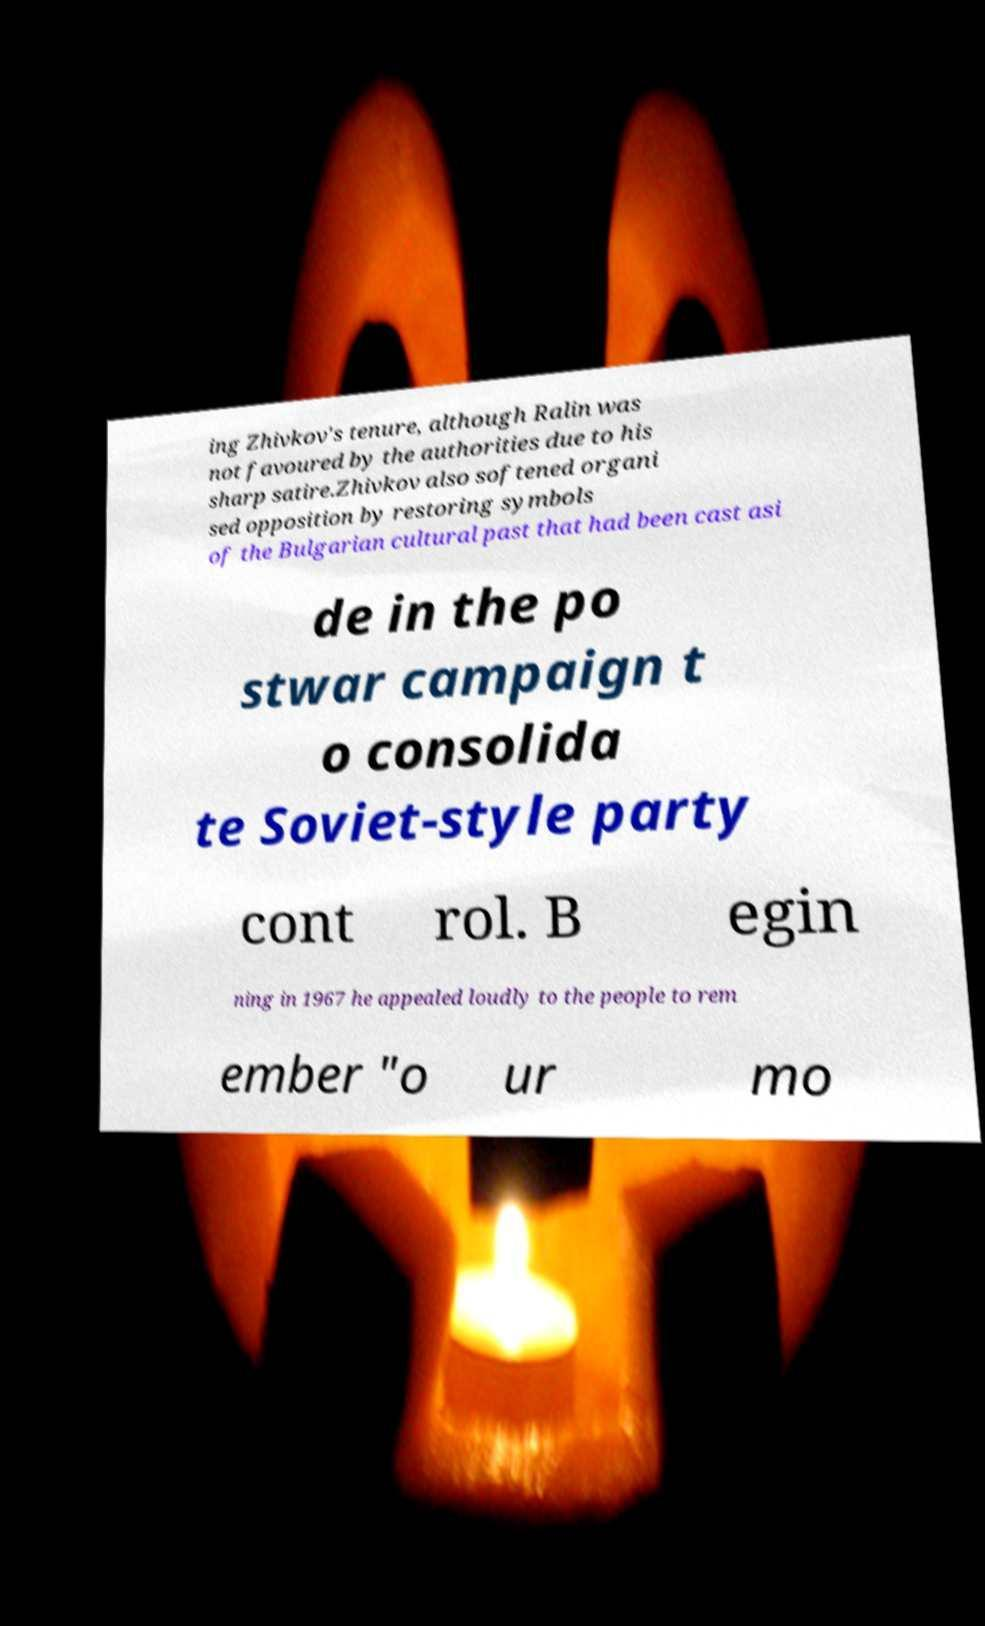Could you assist in decoding the text presented in this image and type it out clearly? ing Zhivkov's tenure, although Ralin was not favoured by the authorities due to his sharp satire.Zhivkov also softened organi sed opposition by restoring symbols of the Bulgarian cultural past that had been cast asi de in the po stwar campaign t o consolida te Soviet-style party cont rol. B egin ning in 1967 he appealed loudly to the people to rem ember "o ur mo 